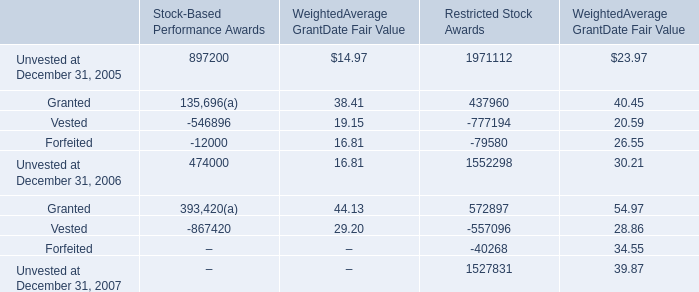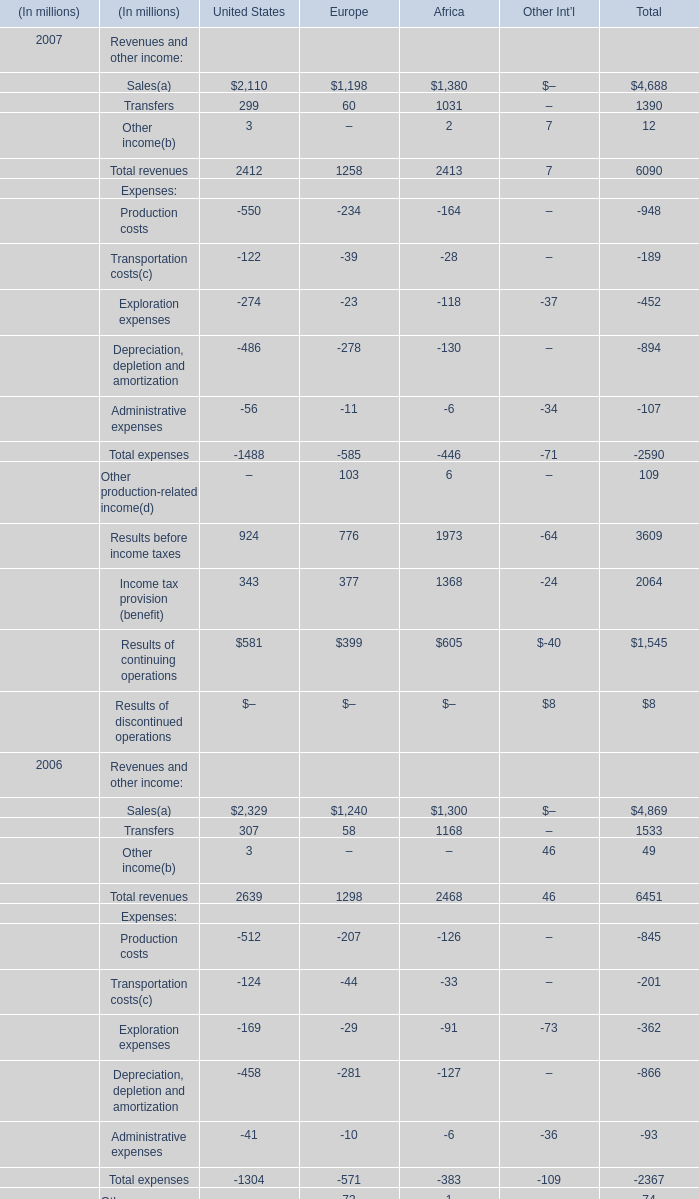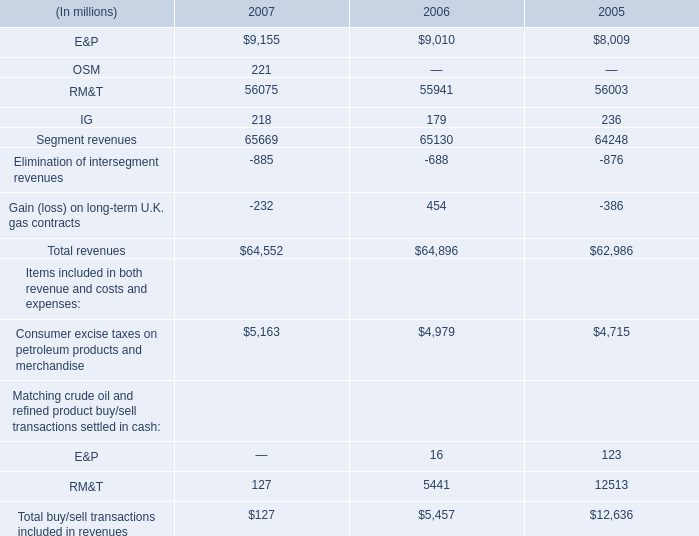Which year is Sales the least in United States ? 
Answer: 2007. 